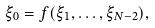Convert formula to latex. <formula><loc_0><loc_0><loc_500><loc_500>\xi _ { 0 } = f ( \xi _ { 1 } , \dots , \xi _ { N - 2 } ) ,</formula> 